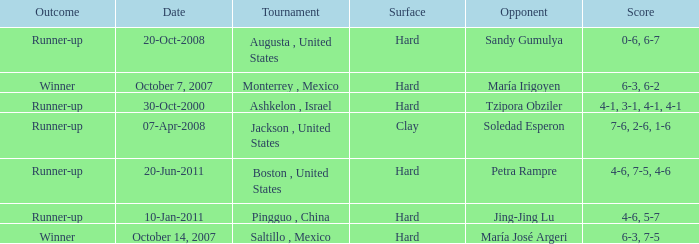What was the outcome when Jing-Jing Lu was the opponent? Runner-up. 